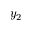Convert formula to latex. <formula><loc_0><loc_0><loc_500><loc_500>y _ { 2 }</formula> 